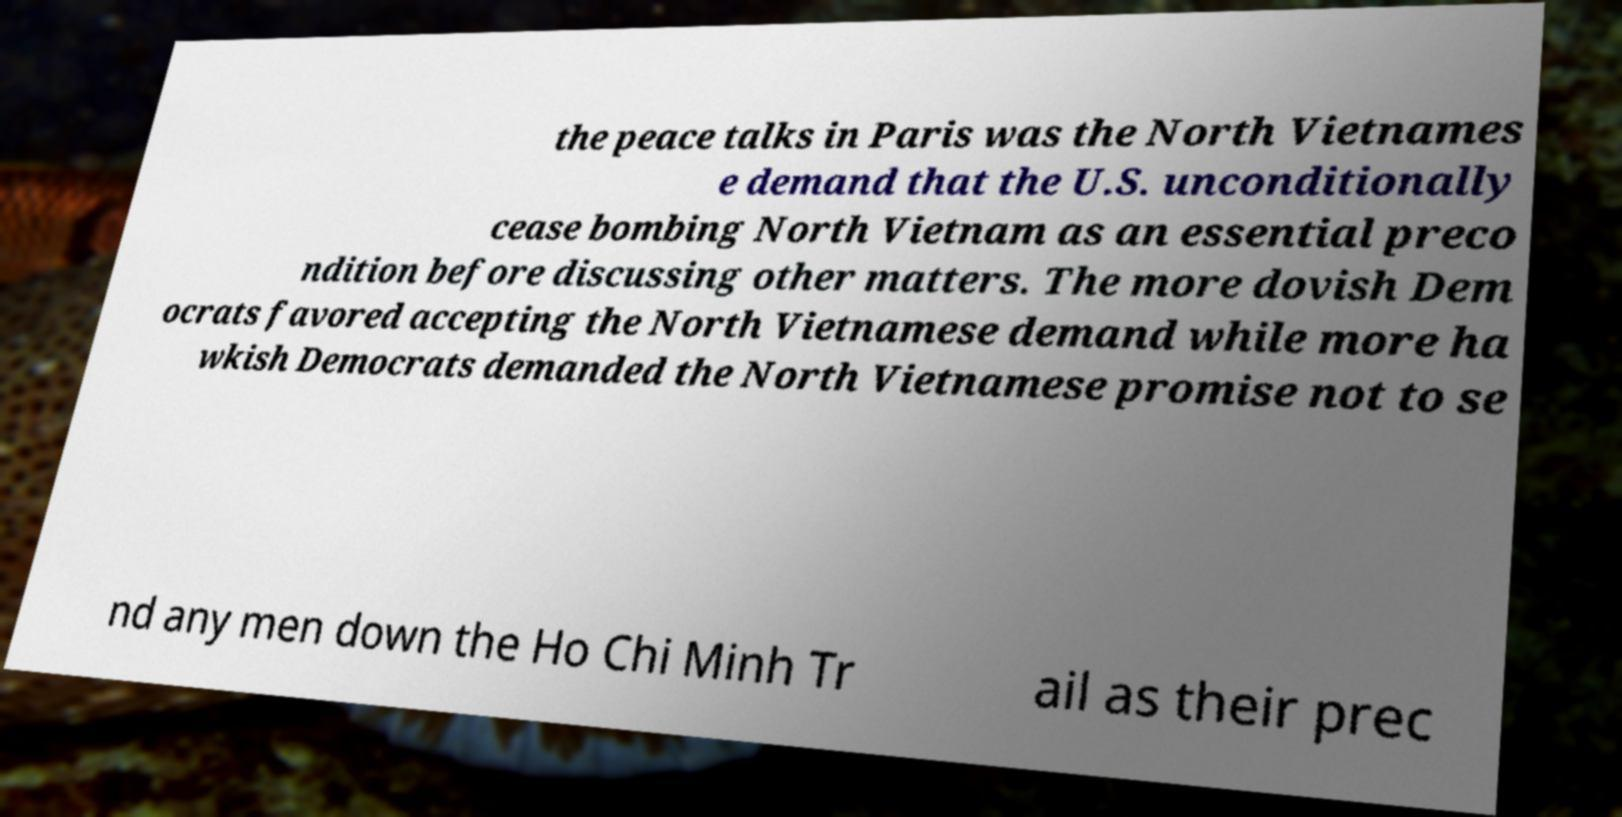Please read and relay the text visible in this image. What does it say? the peace talks in Paris was the North Vietnames e demand that the U.S. unconditionally cease bombing North Vietnam as an essential preco ndition before discussing other matters. The more dovish Dem ocrats favored accepting the North Vietnamese demand while more ha wkish Democrats demanded the North Vietnamese promise not to se nd any men down the Ho Chi Minh Tr ail as their prec 